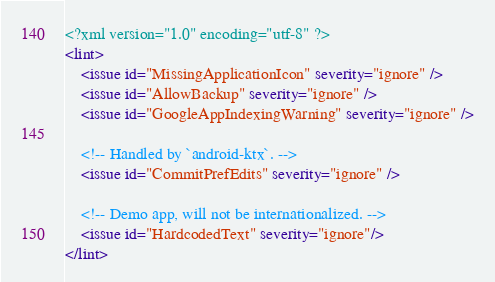<code> <loc_0><loc_0><loc_500><loc_500><_XML_><?xml version="1.0" encoding="utf-8" ?>
<lint>
    <issue id="MissingApplicationIcon" severity="ignore" />
    <issue id="AllowBackup" severity="ignore" />
    <issue id="GoogleAppIndexingWarning" severity="ignore" />

    <!-- Handled by `android-ktx`. -->
    <issue id="CommitPrefEdits" severity="ignore" />

    <!-- Demo app, will not be internationalized. -->
    <issue id="HardcodedText" severity="ignore"/>
</lint></code> 